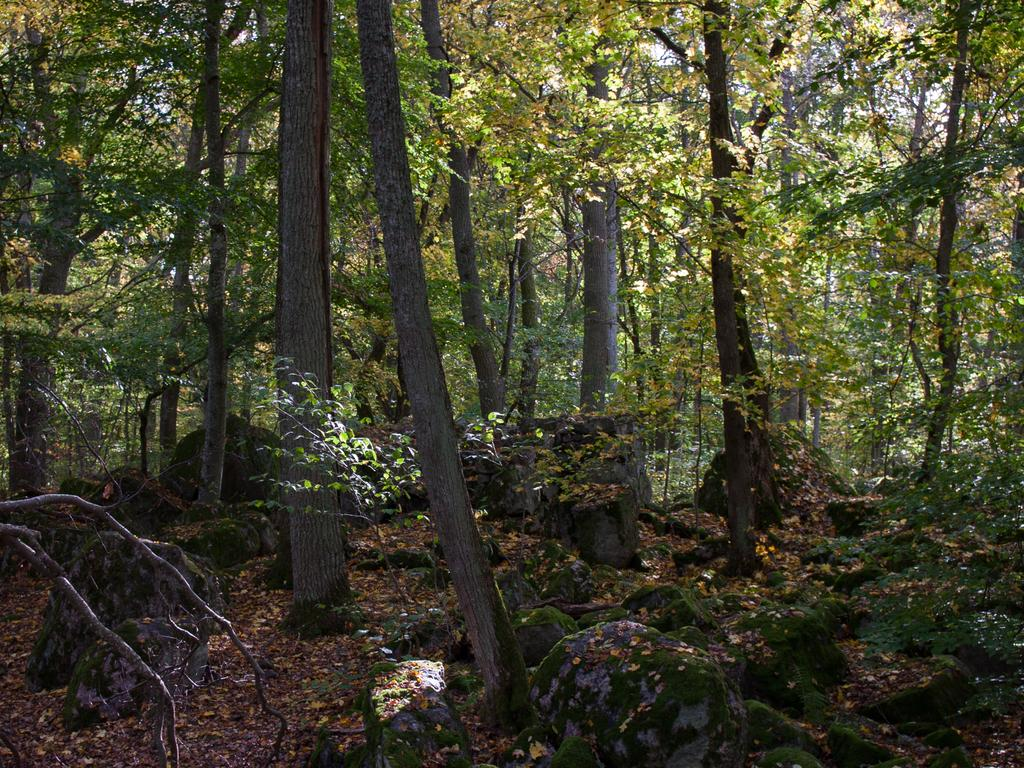What type of natural elements can be seen in the image? There are trees and rocks in the image. What might be covering the ground in the image? Dried leaves are present in the image. What type of play can be seen happening in the image? There is no play or any indication of people or animals in the image. 